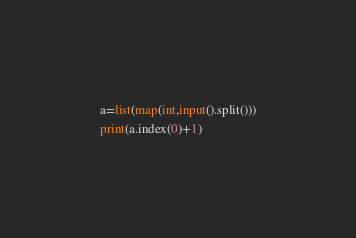<code> <loc_0><loc_0><loc_500><loc_500><_Python_>a=list(map(int,input().split()))
print(a.index(0)+1)
</code> 